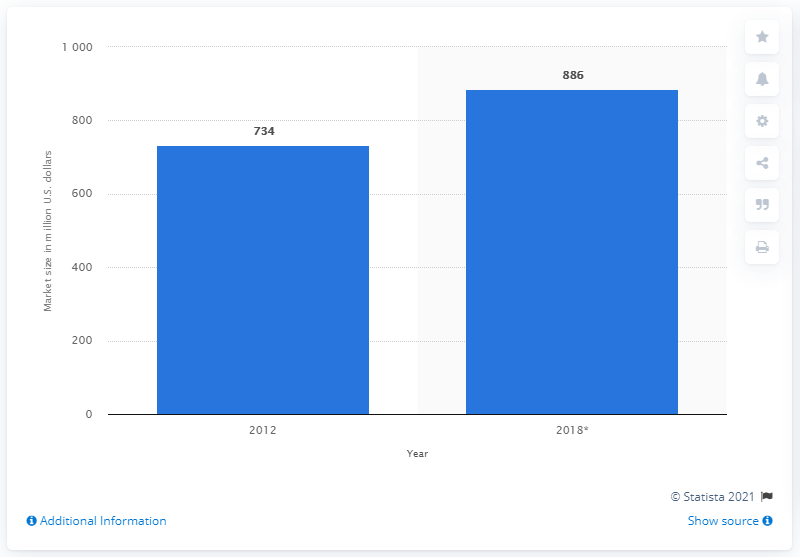Identify some key points in this picture. The market size for organic chocolate between 2012 and 2018 was approximately 734 million dollars. The market size for organic chocolate between 2012 and 2018 was 886 million US dollars. 